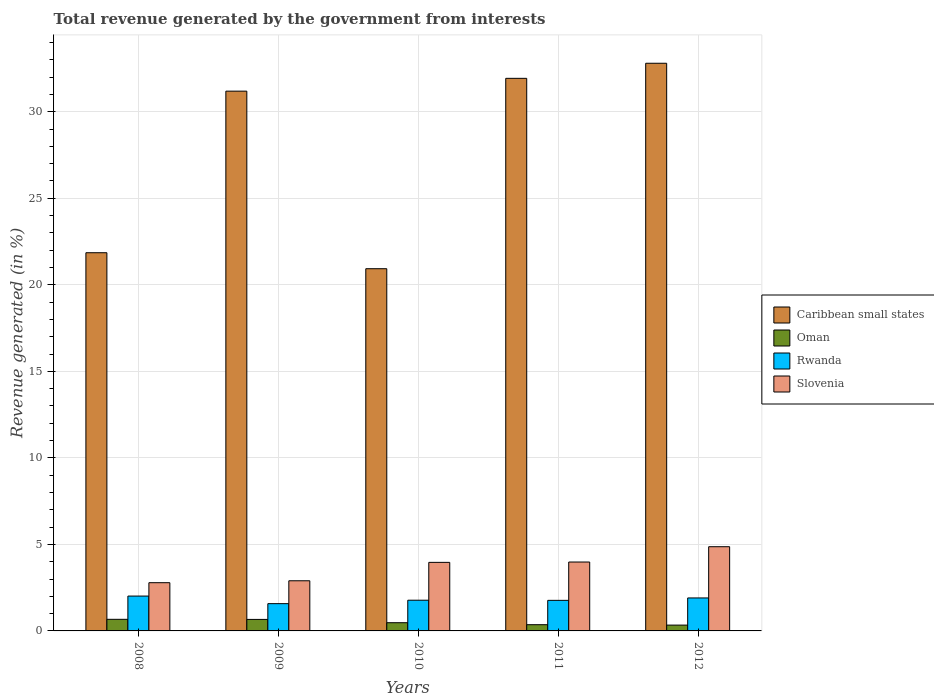How many groups of bars are there?
Your answer should be very brief. 5. In how many cases, is the number of bars for a given year not equal to the number of legend labels?
Give a very brief answer. 0. What is the total revenue generated in Rwanda in 2011?
Your response must be concise. 1.77. Across all years, what is the maximum total revenue generated in Rwanda?
Provide a short and direct response. 2.01. Across all years, what is the minimum total revenue generated in Oman?
Offer a terse response. 0.34. In which year was the total revenue generated in Caribbean small states maximum?
Ensure brevity in your answer.  2012. In which year was the total revenue generated in Caribbean small states minimum?
Provide a short and direct response. 2010. What is the total total revenue generated in Slovenia in the graph?
Your answer should be very brief. 18.49. What is the difference between the total revenue generated in Caribbean small states in 2008 and that in 2012?
Your answer should be very brief. -10.95. What is the difference between the total revenue generated in Caribbean small states in 2011 and the total revenue generated in Oman in 2012?
Keep it short and to the point. 31.59. What is the average total revenue generated in Slovenia per year?
Make the answer very short. 3.7. In the year 2009, what is the difference between the total revenue generated in Rwanda and total revenue generated in Caribbean small states?
Offer a terse response. -29.61. What is the ratio of the total revenue generated in Rwanda in 2008 to that in 2011?
Your answer should be very brief. 1.14. Is the total revenue generated in Rwanda in 2009 less than that in 2010?
Offer a terse response. Yes. Is the difference between the total revenue generated in Rwanda in 2009 and 2011 greater than the difference between the total revenue generated in Caribbean small states in 2009 and 2011?
Your response must be concise. Yes. What is the difference between the highest and the second highest total revenue generated in Caribbean small states?
Your answer should be compact. 0.87. What is the difference between the highest and the lowest total revenue generated in Slovenia?
Your answer should be compact. 2.08. In how many years, is the total revenue generated in Rwanda greater than the average total revenue generated in Rwanda taken over all years?
Make the answer very short. 2. Is the sum of the total revenue generated in Rwanda in 2010 and 2011 greater than the maximum total revenue generated in Oman across all years?
Offer a terse response. Yes. Is it the case that in every year, the sum of the total revenue generated in Oman and total revenue generated in Caribbean small states is greater than the sum of total revenue generated in Rwanda and total revenue generated in Slovenia?
Offer a terse response. No. What does the 3rd bar from the left in 2012 represents?
Offer a terse response. Rwanda. What does the 3rd bar from the right in 2011 represents?
Ensure brevity in your answer.  Oman. Is it the case that in every year, the sum of the total revenue generated in Oman and total revenue generated in Slovenia is greater than the total revenue generated in Caribbean small states?
Your response must be concise. No. How many bars are there?
Your response must be concise. 20. Are all the bars in the graph horizontal?
Offer a very short reply. No. What is the difference between two consecutive major ticks on the Y-axis?
Your answer should be very brief. 5. Are the values on the major ticks of Y-axis written in scientific E-notation?
Provide a short and direct response. No. Where does the legend appear in the graph?
Ensure brevity in your answer.  Center right. How many legend labels are there?
Make the answer very short. 4. How are the legend labels stacked?
Your response must be concise. Vertical. What is the title of the graph?
Make the answer very short. Total revenue generated by the government from interests. What is the label or title of the X-axis?
Make the answer very short. Years. What is the label or title of the Y-axis?
Ensure brevity in your answer.  Revenue generated (in %). What is the Revenue generated (in %) in Caribbean small states in 2008?
Keep it short and to the point. 21.85. What is the Revenue generated (in %) in Oman in 2008?
Your response must be concise. 0.67. What is the Revenue generated (in %) of Rwanda in 2008?
Your response must be concise. 2.01. What is the Revenue generated (in %) of Slovenia in 2008?
Keep it short and to the point. 2.79. What is the Revenue generated (in %) of Caribbean small states in 2009?
Give a very brief answer. 31.19. What is the Revenue generated (in %) of Oman in 2009?
Provide a short and direct response. 0.66. What is the Revenue generated (in %) of Rwanda in 2009?
Offer a terse response. 1.58. What is the Revenue generated (in %) in Slovenia in 2009?
Your response must be concise. 2.9. What is the Revenue generated (in %) in Caribbean small states in 2010?
Offer a very short reply. 20.93. What is the Revenue generated (in %) in Oman in 2010?
Offer a very short reply. 0.47. What is the Revenue generated (in %) of Rwanda in 2010?
Your answer should be compact. 1.77. What is the Revenue generated (in %) of Slovenia in 2010?
Provide a short and direct response. 3.96. What is the Revenue generated (in %) in Caribbean small states in 2011?
Make the answer very short. 31.93. What is the Revenue generated (in %) in Oman in 2011?
Give a very brief answer. 0.36. What is the Revenue generated (in %) in Rwanda in 2011?
Offer a terse response. 1.77. What is the Revenue generated (in %) in Slovenia in 2011?
Ensure brevity in your answer.  3.98. What is the Revenue generated (in %) of Caribbean small states in 2012?
Offer a very short reply. 32.8. What is the Revenue generated (in %) of Oman in 2012?
Offer a very short reply. 0.34. What is the Revenue generated (in %) in Rwanda in 2012?
Provide a short and direct response. 1.91. What is the Revenue generated (in %) in Slovenia in 2012?
Your response must be concise. 4.87. Across all years, what is the maximum Revenue generated (in %) of Caribbean small states?
Your answer should be compact. 32.8. Across all years, what is the maximum Revenue generated (in %) of Oman?
Offer a terse response. 0.67. Across all years, what is the maximum Revenue generated (in %) in Rwanda?
Give a very brief answer. 2.01. Across all years, what is the maximum Revenue generated (in %) in Slovenia?
Ensure brevity in your answer.  4.87. Across all years, what is the minimum Revenue generated (in %) of Caribbean small states?
Make the answer very short. 20.93. Across all years, what is the minimum Revenue generated (in %) in Oman?
Offer a very short reply. 0.34. Across all years, what is the minimum Revenue generated (in %) in Rwanda?
Make the answer very short. 1.58. Across all years, what is the minimum Revenue generated (in %) of Slovenia?
Your answer should be compact. 2.79. What is the total Revenue generated (in %) in Caribbean small states in the graph?
Keep it short and to the point. 138.7. What is the total Revenue generated (in %) of Oman in the graph?
Your answer should be very brief. 2.51. What is the total Revenue generated (in %) in Rwanda in the graph?
Your response must be concise. 9.04. What is the total Revenue generated (in %) in Slovenia in the graph?
Your answer should be compact. 18.49. What is the difference between the Revenue generated (in %) of Caribbean small states in 2008 and that in 2009?
Provide a succinct answer. -9.34. What is the difference between the Revenue generated (in %) of Oman in 2008 and that in 2009?
Ensure brevity in your answer.  0.01. What is the difference between the Revenue generated (in %) of Rwanda in 2008 and that in 2009?
Offer a terse response. 0.44. What is the difference between the Revenue generated (in %) of Slovenia in 2008 and that in 2009?
Your response must be concise. -0.11. What is the difference between the Revenue generated (in %) in Caribbean small states in 2008 and that in 2010?
Provide a succinct answer. 0.92. What is the difference between the Revenue generated (in %) of Oman in 2008 and that in 2010?
Ensure brevity in your answer.  0.2. What is the difference between the Revenue generated (in %) of Rwanda in 2008 and that in 2010?
Your answer should be compact. 0.24. What is the difference between the Revenue generated (in %) of Slovenia in 2008 and that in 2010?
Keep it short and to the point. -1.17. What is the difference between the Revenue generated (in %) in Caribbean small states in 2008 and that in 2011?
Offer a very short reply. -10.08. What is the difference between the Revenue generated (in %) in Oman in 2008 and that in 2011?
Offer a very short reply. 0.31. What is the difference between the Revenue generated (in %) of Rwanda in 2008 and that in 2011?
Offer a very short reply. 0.25. What is the difference between the Revenue generated (in %) of Slovenia in 2008 and that in 2011?
Your response must be concise. -1.19. What is the difference between the Revenue generated (in %) of Caribbean small states in 2008 and that in 2012?
Make the answer very short. -10.95. What is the difference between the Revenue generated (in %) of Oman in 2008 and that in 2012?
Ensure brevity in your answer.  0.33. What is the difference between the Revenue generated (in %) in Rwanda in 2008 and that in 2012?
Make the answer very short. 0.11. What is the difference between the Revenue generated (in %) of Slovenia in 2008 and that in 2012?
Provide a short and direct response. -2.08. What is the difference between the Revenue generated (in %) of Caribbean small states in 2009 and that in 2010?
Provide a succinct answer. 10.26. What is the difference between the Revenue generated (in %) of Oman in 2009 and that in 2010?
Your answer should be compact. 0.19. What is the difference between the Revenue generated (in %) in Rwanda in 2009 and that in 2010?
Your response must be concise. -0.2. What is the difference between the Revenue generated (in %) in Slovenia in 2009 and that in 2010?
Offer a very short reply. -1.06. What is the difference between the Revenue generated (in %) in Caribbean small states in 2009 and that in 2011?
Your response must be concise. -0.74. What is the difference between the Revenue generated (in %) in Oman in 2009 and that in 2011?
Keep it short and to the point. 0.3. What is the difference between the Revenue generated (in %) of Rwanda in 2009 and that in 2011?
Your response must be concise. -0.19. What is the difference between the Revenue generated (in %) in Slovenia in 2009 and that in 2011?
Your answer should be compact. -1.08. What is the difference between the Revenue generated (in %) of Caribbean small states in 2009 and that in 2012?
Offer a terse response. -1.61. What is the difference between the Revenue generated (in %) in Oman in 2009 and that in 2012?
Offer a very short reply. 0.33. What is the difference between the Revenue generated (in %) of Rwanda in 2009 and that in 2012?
Provide a succinct answer. -0.33. What is the difference between the Revenue generated (in %) of Slovenia in 2009 and that in 2012?
Your answer should be very brief. -1.97. What is the difference between the Revenue generated (in %) in Caribbean small states in 2010 and that in 2011?
Offer a terse response. -11. What is the difference between the Revenue generated (in %) in Oman in 2010 and that in 2011?
Provide a short and direct response. 0.11. What is the difference between the Revenue generated (in %) in Rwanda in 2010 and that in 2011?
Offer a terse response. 0.01. What is the difference between the Revenue generated (in %) of Slovenia in 2010 and that in 2011?
Give a very brief answer. -0.02. What is the difference between the Revenue generated (in %) in Caribbean small states in 2010 and that in 2012?
Your answer should be very brief. -11.87. What is the difference between the Revenue generated (in %) of Oman in 2010 and that in 2012?
Offer a very short reply. 0.14. What is the difference between the Revenue generated (in %) in Rwanda in 2010 and that in 2012?
Keep it short and to the point. -0.13. What is the difference between the Revenue generated (in %) of Slovenia in 2010 and that in 2012?
Your response must be concise. -0.9. What is the difference between the Revenue generated (in %) in Caribbean small states in 2011 and that in 2012?
Offer a very short reply. -0.87. What is the difference between the Revenue generated (in %) of Oman in 2011 and that in 2012?
Your response must be concise. 0.02. What is the difference between the Revenue generated (in %) in Rwanda in 2011 and that in 2012?
Offer a very short reply. -0.14. What is the difference between the Revenue generated (in %) in Slovenia in 2011 and that in 2012?
Your answer should be very brief. -0.88. What is the difference between the Revenue generated (in %) of Caribbean small states in 2008 and the Revenue generated (in %) of Oman in 2009?
Offer a very short reply. 21.19. What is the difference between the Revenue generated (in %) of Caribbean small states in 2008 and the Revenue generated (in %) of Rwanda in 2009?
Your answer should be very brief. 20.28. What is the difference between the Revenue generated (in %) of Caribbean small states in 2008 and the Revenue generated (in %) of Slovenia in 2009?
Your response must be concise. 18.95. What is the difference between the Revenue generated (in %) of Oman in 2008 and the Revenue generated (in %) of Rwanda in 2009?
Provide a short and direct response. -0.91. What is the difference between the Revenue generated (in %) of Oman in 2008 and the Revenue generated (in %) of Slovenia in 2009?
Your response must be concise. -2.23. What is the difference between the Revenue generated (in %) in Rwanda in 2008 and the Revenue generated (in %) in Slovenia in 2009?
Offer a terse response. -0.88. What is the difference between the Revenue generated (in %) of Caribbean small states in 2008 and the Revenue generated (in %) of Oman in 2010?
Provide a succinct answer. 21.38. What is the difference between the Revenue generated (in %) in Caribbean small states in 2008 and the Revenue generated (in %) in Rwanda in 2010?
Provide a short and direct response. 20.08. What is the difference between the Revenue generated (in %) of Caribbean small states in 2008 and the Revenue generated (in %) of Slovenia in 2010?
Offer a very short reply. 17.89. What is the difference between the Revenue generated (in %) in Oman in 2008 and the Revenue generated (in %) in Rwanda in 2010?
Your answer should be compact. -1.1. What is the difference between the Revenue generated (in %) of Oman in 2008 and the Revenue generated (in %) of Slovenia in 2010?
Make the answer very short. -3.29. What is the difference between the Revenue generated (in %) of Rwanda in 2008 and the Revenue generated (in %) of Slovenia in 2010?
Your response must be concise. -1.95. What is the difference between the Revenue generated (in %) in Caribbean small states in 2008 and the Revenue generated (in %) in Oman in 2011?
Your response must be concise. 21.49. What is the difference between the Revenue generated (in %) of Caribbean small states in 2008 and the Revenue generated (in %) of Rwanda in 2011?
Your answer should be very brief. 20.09. What is the difference between the Revenue generated (in %) of Caribbean small states in 2008 and the Revenue generated (in %) of Slovenia in 2011?
Ensure brevity in your answer.  17.87. What is the difference between the Revenue generated (in %) of Oman in 2008 and the Revenue generated (in %) of Rwanda in 2011?
Provide a short and direct response. -1.1. What is the difference between the Revenue generated (in %) in Oman in 2008 and the Revenue generated (in %) in Slovenia in 2011?
Ensure brevity in your answer.  -3.31. What is the difference between the Revenue generated (in %) in Rwanda in 2008 and the Revenue generated (in %) in Slovenia in 2011?
Your answer should be very brief. -1.97. What is the difference between the Revenue generated (in %) in Caribbean small states in 2008 and the Revenue generated (in %) in Oman in 2012?
Provide a short and direct response. 21.52. What is the difference between the Revenue generated (in %) of Caribbean small states in 2008 and the Revenue generated (in %) of Rwanda in 2012?
Your answer should be very brief. 19.95. What is the difference between the Revenue generated (in %) in Caribbean small states in 2008 and the Revenue generated (in %) in Slovenia in 2012?
Ensure brevity in your answer.  16.99. What is the difference between the Revenue generated (in %) in Oman in 2008 and the Revenue generated (in %) in Rwanda in 2012?
Ensure brevity in your answer.  -1.24. What is the difference between the Revenue generated (in %) in Oman in 2008 and the Revenue generated (in %) in Slovenia in 2012?
Make the answer very short. -4.2. What is the difference between the Revenue generated (in %) in Rwanda in 2008 and the Revenue generated (in %) in Slovenia in 2012?
Provide a short and direct response. -2.85. What is the difference between the Revenue generated (in %) in Caribbean small states in 2009 and the Revenue generated (in %) in Oman in 2010?
Offer a very short reply. 30.71. What is the difference between the Revenue generated (in %) in Caribbean small states in 2009 and the Revenue generated (in %) in Rwanda in 2010?
Provide a short and direct response. 29.41. What is the difference between the Revenue generated (in %) of Caribbean small states in 2009 and the Revenue generated (in %) of Slovenia in 2010?
Your answer should be very brief. 27.23. What is the difference between the Revenue generated (in %) in Oman in 2009 and the Revenue generated (in %) in Rwanda in 2010?
Your response must be concise. -1.11. What is the difference between the Revenue generated (in %) of Oman in 2009 and the Revenue generated (in %) of Slovenia in 2010?
Make the answer very short. -3.3. What is the difference between the Revenue generated (in %) in Rwanda in 2009 and the Revenue generated (in %) in Slovenia in 2010?
Your response must be concise. -2.39. What is the difference between the Revenue generated (in %) in Caribbean small states in 2009 and the Revenue generated (in %) in Oman in 2011?
Your answer should be very brief. 30.83. What is the difference between the Revenue generated (in %) in Caribbean small states in 2009 and the Revenue generated (in %) in Rwanda in 2011?
Ensure brevity in your answer.  29.42. What is the difference between the Revenue generated (in %) of Caribbean small states in 2009 and the Revenue generated (in %) of Slovenia in 2011?
Make the answer very short. 27.21. What is the difference between the Revenue generated (in %) in Oman in 2009 and the Revenue generated (in %) in Rwanda in 2011?
Ensure brevity in your answer.  -1.1. What is the difference between the Revenue generated (in %) of Oman in 2009 and the Revenue generated (in %) of Slovenia in 2011?
Provide a short and direct response. -3.32. What is the difference between the Revenue generated (in %) of Rwanda in 2009 and the Revenue generated (in %) of Slovenia in 2011?
Provide a short and direct response. -2.4. What is the difference between the Revenue generated (in %) in Caribbean small states in 2009 and the Revenue generated (in %) in Oman in 2012?
Your response must be concise. 30.85. What is the difference between the Revenue generated (in %) of Caribbean small states in 2009 and the Revenue generated (in %) of Rwanda in 2012?
Your answer should be compact. 29.28. What is the difference between the Revenue generated (in %) of Caribbean small states in 2009 and the Revenue generated (in %) of Slovenia in 2012?
Give a very brief answer. 26.32. What is the difference between the Revenue generated (in %) of Oman in 2009 and the Revenue generated (in %) of Rwanda in 2012?
Your answer should be very brief. -1.24. What is the difference between the Revenue generated (in %) in Oman in 2009 and the Revenue generated (in %) in Slovenia in 2012?
Keep it short and to the point. -4.2. What is the difference between the Revenue generated (in %) in Rwanda in 2009 and the Revenue generated (in %) in Slovenia in 2012?
Offer a very short reply. -3.29. What is the difference between the Revenue generated (in %) of Caribbean small states in 2010 and the Revenue generated (in %) of Oman in 2011?
Offer a very short reply. 20.57. What is the difference between the Revenue generated (in %) of Caribbean small states in 2010 and the Revenue generated (in %) of Rwanda in 2011?
Provide a short and direct response. 19.16. What is the difference between the Revenue generated (in %) in Caribbean small states in 2010 and the Revenue generated (in %) in Slovenia in 2011?
Provide a short and direct response. 16.95. What is the difference between the Revenue generated (in %) of Oman in 2010 and the Revenue generated (in %) of Rwanda in 2011?
Provide a succinct answer. -1.29. What is the difference between the Revenue generated (in %) in Oman in 2010 and the Revenue generated (in %) in Slovenia in 2011?
Provide a succinct answer. -3.51. What is the difference between the Revenue generated (in %) of Rwanda in 2010 and the Revenue generated (in %) of Slovenia in 2011?
Your answer should be very brief. -2.21. What is the difference between the Revenue generated (in %) of Caribbean small states in 2010 and the Revenue generated (in %) of Oman in 2012?
Your answer should be compact. 20.59. What is the difference between the Revenue generated (in %) in Caribbean small states in 2010 and the Revenue generated (in %) in Rwanda in 2012?
Make the answer very short. 19.02. What is the difference between the Revenue generated (in %) in Caribbean small states in 2010 and the Revenue generated (in %) in Slovenia in 2012?
Provide a short and direct response. 16.06. What is the difference between the Revenue generated (in %) in Oman in 2010 and the Revenue generated (in %) in Rwanda in 2012?
Your answer should be very brief. -1.43. What is the difference between the Revenue generated (in %) in Oman in 2010 and the Revenue generated (in %) in Slovenia in 2012?
Offer a very short reply. -4.39. What is the difference between the Revenue generated (in %) in Rwanda in 2010 and the Revenue generated (in %) in Slovenia in 2012?
Offer a terse response. -3.09. What is the difference between the Revenue generated (in %) in Caribbean small states in 2011 and the Revenue generated (in %) in Oman in 2012?
Give a very brief answer. 31.59. What is the difference between the Revenue generated (in %) of Caribbean small states in 2011 and the Revenue generated (in %) of Rwanda in 2012?
Your response must be concise. 30.02. What is the difference between the Revenue generated (in %) of Caribbean small states in 2011 and the Revenue generated (in %) of Slovenia in 2012?
Provide a short and direct response. 27.06. What is the difference between the Revenue generated (in %) in Oman in 2011 and the Revenue generated (in %) in Rwanda in 2012?
Offer a very short reply. -1.55. What is the difference between the Revenue generated (in %) of Oman in 2011 and the Revenue generated (in %) of Slovenia in 2012?
Offer a terse response. -4.51. What is the difference between the Revenue generated (in %) of Rwanda in 2011 and the Revenue generated (in %) of Slovenia in 2012?
Provide a succinct answer. -3.1. What is the average Revenue generated (in %) of Caribbean small states per year?
Your answer should be compact. 27.74. What is the average Revenue generated (in %) in Oman per year?
Offer a very short reply. 0.5. What is the average Revenue generated (in %) of Rwanda per year?
Keep it short and to the point. 1.81. What is the average Revenue generated (in %) of Slovenia per year?
Your answer should be compact. 3.7. In the year 2008, what is the difference between the Revenue generated (in %) of Caribbean small states and Revenue generated (in %) of Oman?
Your answer should be very brief. 21.18. In the year 2008, what is the difference between the Revenue generated (in %) in Caribbean small states and Revenue generated (in %) in Rwanda?
Offer a terse response. 19.84. In the year 2008, what is the difference between the Revenue generated (in %) in Caribbean small states and Revenue generated (in %) in Slovenia?
Offer a very short reply. 19.07. In the year 2008, what is the difference between the Revenue generated (in %) of Oman and Revenue generated (in %) of Rwanda?
Offer a very short reply. -1.34. In the year 2008, what is the difference between the Revenue generated (in %) of Oman and Revenue generated (in %) of Slovenia?
Your answer should be very brief. -2.12. In the year 2008, what is the difference between the Revenue generated (in %) in Rwanda and Revenue generated (in %) in Slovenia?
Offer a terse response. -0.77. In the year 2009, what is the difference between the Revenue generated (in %) of Caribbean small states and Revenue generated (in %) of Oman?
Make the answer very short. 30.52. In the year 2009, what is the difference between the Revenue generated (in %) in Caribbean small states and Revenue generated (in %) in Rwanda?
Keep it short and to the point. 29.61. In the year 2009, what is the difference between the Revenue generated (in %) in Caribbean small states and Revenue generated (in %) in Slovenia?
Provide a short and direct response. 28.29. In the year 2009, what is the difference between the Revenue generated (in %) of Oman and Revenue generated (in %) of Rwanda?
Provide a succinct answer. -0.91. In the year 2009, what is the difference between the Revenue generated (in %) of Oman and Revenue generated (in %) of Slovenia?
Make the answer very short. -2.23. In the year 2009, what is the difference between the Revenue generated (in %) of Rwanda and Revenue generated (in %) of Slovenia?
Provide a short and direct response. -1.32. In the year 2010, what is the difference between the Revenue generated (in %) in Caribbean small states and Revenue generated (in %) in Oman?
Provide a succinct answer. 20.45. In the year 2010, what is the difference between the Revenue generated (in %) in Caribbean small states and Revenue generated (in %) in Rwanda?
Make the answer very short. 19.16. In the year 2010, what is the difference between the Revenue generated (in %) in Caribbean small states and Revenue generated (in %) in Slovenia?
Your response must be concise. 16.97. In the year 2010, what is the difference between the Revenue generated (in %) of Oman and Revenue generated (in %) of Rwanda?
Your answer should be compact. -1.3. In the year 2010, what is the difference between the Revenue generated (in %) of Oman and Revenue generated (in %) of Slovenia?
Offer a terse response. -3.49. In the year 2010, what is the difference between the Revenue generated (in %) of Rwanda and Revenue generated (in %) of Slovenia?
Provide a short and direct response. -2.19. In the year 2011, what is the difference between the Revenue generated (in %) in Caribbean small states and Revenue generated (in %) in Oman?
Your answer should be very brief. 31.57. In the year 2011, what is the difference between the Revenue generated (in %) of Caribbean small states and Revenue generated (in %) of Rwanda?
Your answer should be very brief. 30.16. In the year 2011, what is the difference between the Revenue generated (in %) in Caribbean small states and Revenue generated (in %) in Slovenia?
Provide a succinct answer. 27.95. In the year 2011, what is the difference between the Revenue generated (in %) in Oman and Revenue generated (in %) in Rwanda?
Your response must be concise. -1.41. In the year 2011, what is the difference between the Revenue generated (in %) in Oman and Revenue generated (in %) in Slovenia?
Provide a short and direct response. -3.62. In the year 2011, what is the difference between the Revenue generated (in %) of Rwanda and Revenue generated (in %) of Slovenia?
Offer a terse response. -2.21. In the year 2012, what is the difference between the Revenue generated (in %) of Caribbean small states and Revenue generated (in %) of Oman?
Ensure brevity in your answer.  32.46. In the year 2012, what is the difference between the Revenue generated (in %) in Caribbean small states and Revenue generated (in %) in Rwanda?
Offer a terse response. 30.9. In the year 2012, what is the difference between the Revenue generated (in %) of Caribbean small states and Revenue generated (in %) of Slovenia?
Your response must be concise. 27.94. In the year 2012, what is the difference between the Revenue generated (in %) of Oman and Revenue generated (in %) of Rwanda?
Ensure brevity in your answer.  -1.57. In the year 2012, what is the difference between the Revenue generated (in %) in Oman and Revenue generated (in %) in Slovenia?
Your answer should be compact. -4.53. In the year 2012, what is the difference between the Revenue generated (in %) of Rwanda and Revenue generated (in %) of Slovenia?
Offer a terse response. -2.96. What is the ratio of the Revenue generated (in %) in Caribbean small states in 2008 to that in 2009?
Ensure brevity in your answer.  0.7. What is the ratio of the Revenue generated (in %) in Oman in 2008 to that in 2009?
Provide a succinct answer. 1.01. What is the ratio of the Revenue generated (in %) of Rwanda in 2008 to that in 2009?
Ensure brevity in your answer.  1.28. What is the ratio of the Revenue generated (in %) of Slovenia in 2008 to that in 2009?
Ensure brevity in your answer.  0.96. What is the ratio of the Revenue generated (in %) of Caribbean small states in 2008 to that in 2010?
Offer a very short reply. 1.04. What is the ratio of the Revenue generated (in %) of Oman in 2008 to that in 2010?
Offer a terse response. 1.41. What is the ratio of the Revenue generated (in %) of Rwanda in 2008 to that in 2010?
Your response must be concise. 1.14. What is the ratio of the Revenue generated (in %) of Slovenia in 2008 to that in 2010?
Offer a terse response. 0.7. What is the ratio of the Revenue generated (in %) in Caribbean small states in 2008 to that in 2011?
Offer a very short reply. 0.68. What is the ratio of the Revenue generated (in %) of Oman in 2008 to that in 2011?
Your response must be concise. 1.86. What is the ratio of the Revenue generated (in %) in Rwanda in 2008 to that in 2011?
Keep it short and to the point. 1.14. What is the ratio of the Revenue generated (in %) of Slovenia in 2008 to that in 2011?
Give a very brief answer. 0.7. What is the ratio of the Revenue generated (in %) of Caribbean small states in 2008 to that in 2012?
Make the answer very short. 0.67. What is the ratio of the Revenue generated (in %) in Oman in 2008 to that in 2012?
Offer a very short reply. 1.99. What is the ratio of the Revenue generated (in %) in Rwanda in 2008 to that in 2012?
Your response must be concise. 1.06. What is the ratio of the Revenue generated (in %) of Slovenia in 2008 to that in 2012?
Provide a short and direct response. 0.57. What is the ratio of the Revenue generated (in %) in Caribbean small states in 2009 to that in 2010?
Provide a succinct answer. 1.49. What is the ratio of the Revenue generated (in %) in Oman in 2009 to that in 2010?
Give a very brief answer. 1.4. What is the ratio of the Revenue generated (in %) in Rwanda in 2009 to that in 2010?
Offer a terse response. 0.89. What is the ratio of the Revenue generated (in %) of Slovenia in 2009 to that in 2010?
Make the answer very short. 0.73. What is the ratio of the Revenue generated (in %) in Caribbean small states in 2009 to that in 2011?
Your answer should be compact. 0.98. What is the ratio of the Revenue generated (in %) in Oman in 2009 to that in 2011?
Keep it short and to the point. 1.85. What is the ratio of the Revenue generated (in %) in Rwanda in 2009 to that in 2011?
Ensure brevity in your answer.  0.89. What is the ratio of the Revenue generated (in %) of Slovenia in 2009 to that in 2011?
Make the answer very short. 0.73. What is the ratio of the Revenue generated (in %) of Caribbean small states in 2009 to that in 2012?
Provide a succinct answer. 0.95. What is the ratio of the Revenue generated (in %) of Oman in 2009 to that in 2012?
Your answer should be very brief. 1.97. What is the ratio of the Revenue generated (in %) of Rwanda in 2009 to that in 2012?
Ensure brevity in your answer.  0.83. What is the ratio of the Revenue generated (in %) in Slovenia in 2009 to that in 2012?
Keep it short and to the point. 0.6. What is the ratio of the Revenue generated (in %) in Caribbean small states in 2010 to that in 2011?
Keep it short and to the point. 0.66. What is the ratio of the Revenue generated (in %) of Oman in 2010 to that in 2011?
Provide a succinct answer. 1.32. What is the ratio of the Revenue generated (in %) in Slovenia in 2010 to that in 2011?
Ensure brevity in your answer.  1. What is the ratio of the Revenue generated (in %) in Caribbean small states in 2010 to that in 2012?
Give a very brief answer. 0.64. What is the ratio of the Revenue generated (in %) in Oman in 2010 to that in 2012?
Provide a succinct answer. 1.41. What is the ratio of the Revenue generated (in %) of Rwanda in 2010 to that in 2012?
Ensure brevity in your answer.  0.93. What is the ratio of the Revenue generated (in %) in Slovenia in 2010 to that in 2012?
Ensure brevity in your answer.  0.81. What is the ratio of the Revenue generated (in %) in Caribbean small states in 2011 to that in 2012?
Ensure brevity in your answer.  0.97. What is the ratio of the Revenue generated (in %) in Oman in 2011 to that in 2012?
Your answer should be very brief. 1.07. What is the ratio of the Revenue generated (in %) in Rwanda in 2011 to that in 2012?
Your answer should be compact. 0.93. What is the ratio of the Revenue generated (in %) of Slovenia in 2011 to that in 2012?
Keep it short and to the point. 0.82. What is the difference between the highest and the second highest Revenue generated (in %) in Caribbean small states?
Make the answer very short. 0.87. What is the difference between the highest and the second highest Revenue generated (in %) in Oman?
Ensure brevity in your answer.  0.01. What is the difference between the highest and the second highest Revenue generated (in %) in Rwanda?
Make the answer very short. 0.11. What is the difference between the highest and the second highest Revenue generated (in %) of Slovenia?
Offer a terse response. 0.88. What is the difference between the highest and the lowest Revenue generated (in %) of Caribbean small states?
Ensure brevity in your answer.  11.87. What is the difference between the highest and the lowest Revenue generated (in %) of Oman?
Provide a short and direct response. 0.33. What is the difference between the highest and the lowest Revenue generated (in %) of Rwanda?
Offer a terse response. 0.44. What is the difference between the highest and the lowest Revenue generated (in %) in Slovenia?
Provide a short and direct response. 2.08. 